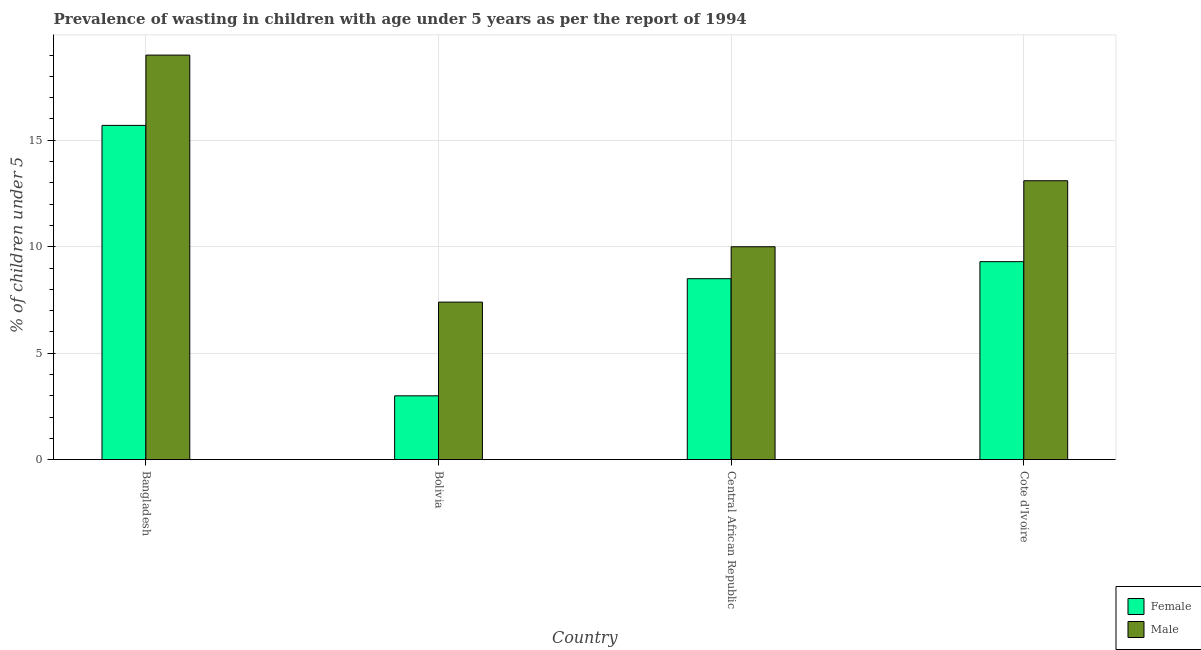How many groups of bars are there?
Offer a terse response. 4. Are the number of bars per tick equal to the number of legend labels?
Your answer should be very brief. Yes. How many bars are there on the 4th tick from the left?
Your response must be concise. 2. What is the label of the 3rd group of bars from the left?
Your response must be concise. Central African Republic. Across all countries, what is the minimum percentage of undernourished female children?
Your answer should be compact. 3. In which country was the percentage of undernourished female children maximum?
Your answer should be compact. Bangladesh. In which country was the percentage of undernourished male children minimum?
Your answer should be very brief. Bolivia. What is the total percentage of undernourished female children in the graph?
Provide a short and direct response. 36.5. What is the difference between the percentage of undernourished male children in Bangladesh and that in Bolivia?
Offer a very short reply. 11.6. What is the difference between the percentage of undernourished male children in Central African Republic and the percentage of undernourished female children in Cote d'Ivoire?
Ensure brevity in your answer.  0.7. What is the average percentage of undernourished female children per country?
Provide a short and direct response. 9.12. What is the difference between the percentage of undernourished female children and percentage of undernourished male children in Bangladesh?
Provide a short and direct response. -3.3. What is the ratio of the percentage of undernourished male children in Bangladesh to that in Bolivia?
Ensure brevity in your answer.  2.57. Is the percentage of undernourished male children in Central African Republic less than that in Cote d'Ivoire?
Offer a very short reply. Yes. Is the difference between the percentage of undernourished female children in Bangladesh and Cote d'Ivoire greater than the difference between the percentage of undernourished male children in Bangladesh and Cote d'Ivoire?
Offer a very short reply. Yes. What is the difference between the highest and the second highest percentage of undernourished male children?
Keep it short and to the point. 5.9. What is the difference between the highest and the lowest percentage of undernourished female children?
Ensure brevity in your answer.  12.7. What does the 2nd bar from the left in Central African Republic represents?
Offer a terse response. Male. What does the 2nd bar from the right in Central African Republic represents?
Your response must be concise. Female. How many bars are there?
Provide a succinct answer. 8. What is the difference between two consecutive major ticks on the Y-axis?
Offer a terse response. 5. What is the title of the graph?
Ensure brevity in your answer.  Prevalence of wasting in children with age under 5 years as per the report of 1994. What is the label or title of the Y-axis?
Your answer should be compact.  % of children under 5. What is the  % of children under 5 in Female in Bangladesh?
Ensure brevity in your answer.  15.7. What is the  % of children under 5 of Male in Bangladesh?
Ensure brevity in your answer.  19. What is the  % of children under 5 in Female in Bolivia?
Keep it short and to the point. 3. What is the  % of children under 5 in Male in Bolivia?
Offer a terse response. 7.4. What is the  % of children under 5 in Female in Cote d'Ivoire?
Provide a short and direct response. 9.3. What is the  % of children under 5 in Male in Cote d'Ivoire?
Keep it short and to the point. 13.1. Across all countries, what is the maximum  % of children under 5 in Female?
Keep it short and to the point. 15.7. Across all countries, what is the minimum  % of children under 5 of Male?
Make the answer very short. 7.4. What is the total  % of children under 5 of Female in the graph?
Your response must be concise. 36.5. What is the total  % of children under 5 in Male in the graph?
Ensure brevity in your answer.  49.5. What is the difference between the  % of children under 5 in Female in Bangladesh and that in Bolivia?
Keep it short and to the point. 12.7. What is the difference between the  % of children under 5 in Male in Bangladesh and that in Central African Republic?
Give a very brief answer. 9. What is the difference between the  % of children under 5 of Female in Bangladesh and that in Cote d'Ivoire?
Your answer should be compact. 6.4. What is the difference between the  % of children under 5 of Female in Bolivia and that in Central African Republic?
Offer a very short reply. -5.5. What is the difference between the  % of children under 5 in Female in Bolivia and that in Cote d'Ivoire?
Make the answer very short. -6.3. What is the difference between the  % of children under 5 in Female in Central African Republic and that in Cote d'Ivoire?
Give a very brief answer. -0.8. What is the difference between the  % of children under 5 of Male in Central African Republic and that in Cote d'Ivoire?
Provide a short and direct response. -3.1. What is the difference between the  % of children under 5 in Female in Bangladesh and the  % of children under 5 in Male in Bolivia?
Offer a terse response. 8.3. What is the difference between the  % of children under 5 in Female in Bangladesh and the  % of children under 5 in Male in Central African Republic?
Make the answer very short. 5.7. What is the difference between the  % of children under 5 of Female in Central African Republic and the  % of children under 5 of Male in Cote d'Ivoire?
Keep it short and to the point. -4.6. What is the average  % of children under 5 in Female per country?
Keep it short and to the point. 9.12. What is the average  % of children under 5 in Male per country?
Your response must be concise. 12.38. What is the difference between the  % of children under 5 in Female and  % of children under 5 in Male in Bangladesh?
Make the answer very short. -3.3. What is the difference between the  % of children under 5 of Female and  % of children under 5 of Male in Bolivia?
Offer a very short reply. -4.4. What is the difference between the  % of children under 5 in Female and  % of children under 5 in Male in Cote d'Ivoire?
Ensure brevity in your answer.  -3.8. What is the ratio of the  % of children under 5 of Female in Bangladesh to that in Bolivia?
Provide a succinct answer. 5.23. What is the ratio of the  % of children under 5 in Male in Bangladesh to that in Bolivia?
Offer a very short reply. 2.57. What is the ratio of the  % of children under 5 in Female in Bangladesh to that in Central African Republic?
Ensure brevity in your answer.  1.85. What is the ratio of the  % of children under 5 in Male in Bangladesh to that in Central African Republic?
Provide a succinct answer. 1.9. What is the ratio of the  % of children under 5 of Female in Bangladesh to that in Cote d'Ivoire?
Provide a succinct answer. 1.69. What is the ratio of the  % of children under 5 in Male in Bangladesh to that in Cote d'Ivoire?
Give a very brief answer. 1.45. What is the ratio of the  % of children under 5 of Female in Bolivia to that in Central African Republic?
Provide a succinct answer. 0.35. What is the ratio of the  % of children under 5 in Male in Bolivia to that in Central African Republic?
Keep it short and to the point. 0.74. What is the ratio of the  % of children under 5 in Female in Bolivia to that in Cote d'Ivoire?
Ensure brevity in your answer.  0.32. What is the ratio of the  % of children under 5 of Male in Bolivia to that in Cote d'Ivoire?
Ensure brevity in your answer.  0.56. What is the ratio of the  % of children under 5 of Female in Central African Republic to that in Cote d'Ivoire?
Make the answer very short. 0.91. What is the ratio of the  % of children under 5 in Male in Central African Republic to that in Cote d'Ivoire?
Ensure brevity in your answer.  0.76. What is the difference between the highest and the second highest  % of children under 5 in Female?
Your answer should be very brief. 6.4. What is the difference between the highest and the second highest  % of children under 5 in Male?
Your answer should be very brief. 5.9. 